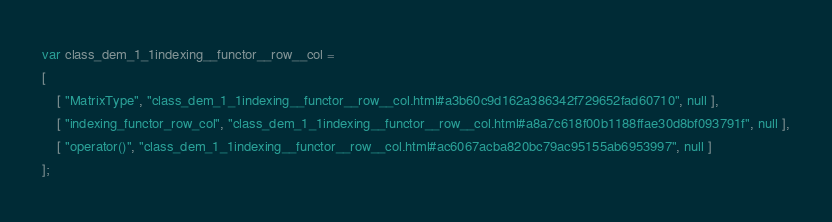<code> <loc_0><loc_0><loc_500><loc_500><_JavaScript_>var class_dem_1_1indexing__functor__row__col =
[
    [ "MatrixType", "class_dem_1_1indexing__functor__row__col.html#a3b60c9d162a386342f729652fad60710", null ],
    [ "indexing_functor_row_col", "class_dem_1_1indexing__functor__row__col.html#a8a7c618f00b1188ffae30d8bf093791f", null ],
    [ "operator()", "class_dem_1_1indexing__functor__row__col.html#ac6067acba820bc79ac95155ab6953997", null ]
];</code> 